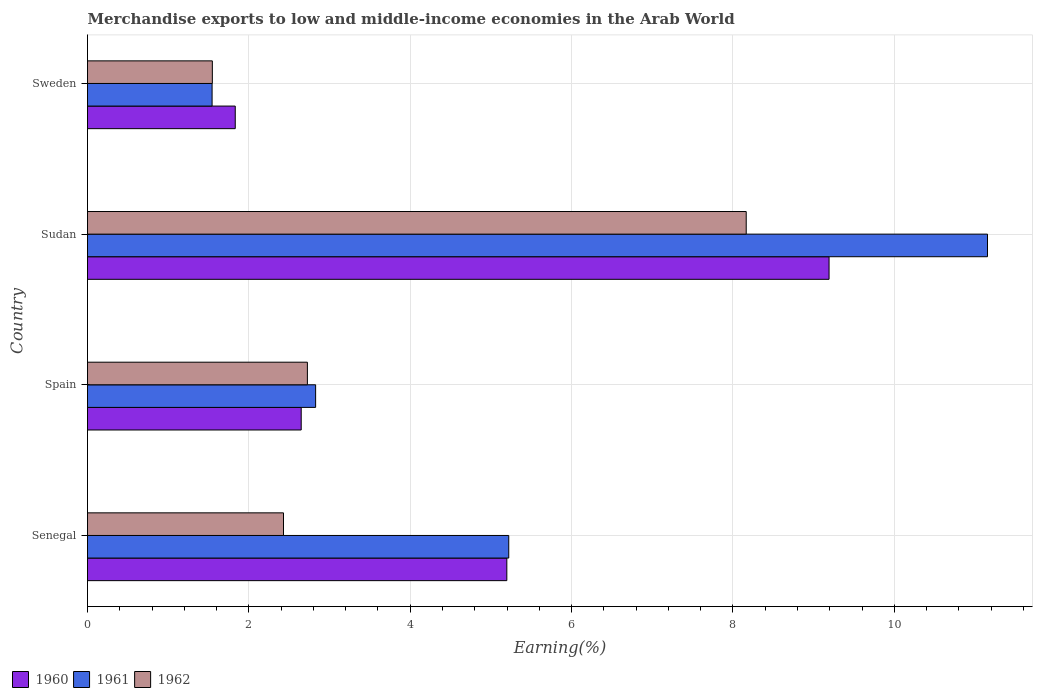Are the number of bars per tick equal to the number of legend labels?
Keep it short and to the point. Yes. How many bars are there on the 2nd tick from the bottom?
Provide a succinct answer. 3. What is the label of the 2nd group of bars from the top?
Provide a succinct answer. Sudan. In how many cases, is the number of bars for a given country not equal to the number of legend labels?
Your answer should be compact. 0. What is the percentage of amount earned from merchandise exports in 1960 in Spain?
Ensure brevity in your answer.  2.65. Across all countries, what is the maximum percentage of amount earned from merchandise exports in 1961?
Offer a terse response. 11.15. Across all countries, what is the minimum percentage of amount earned from merchandise exports in 1961?
Your answer should be compact. 1.54. In which country was the percentage of amount earned from merchandise exports in 1962 maximum?
Provide a succinct answer. Sudan. In which country was the percentage of amount earned from merchandise exports in 1962 minimum?
Provide a short and direct response. Sweden. What is the total percentage of amount earned from merchandise exports in 1962 in the graph?
Your response must be concise. 14.87. What is the difference between the percentage of amount earned from merchandise exports in 1962 in Senegal and that in Sudan?
Offer a terse response. -5.74. What is the difference between the percentage of amount earned from merchandise exports in 1961 in Sudan and the percentage of amount earned from merchandise exports in 1962 in Senegal?
Give a very brief answer. 8.73. What is the average percentage of amount earned from merchandise exports in 1961 per country?
Offer a terse response. 5.19. What is the difference between the percentage of amount earned from merchandise exports in 1961 and percentage of amount earned from merchandise exports in 1962 in Sweden?
Make the answer very short. -0. In how many countries, is the percentage of amount earned from merchandise exports in 1961 greater than 3.2 %?
Provide a succinct answer. 2. What is the ratio of the percentage of amount earned from merchandise exports in 1962 in Senegal to that in Sweden?
Your answer should be very brief. 1.57. What is the difference between the highest and the second highest percentage of amount earned from merchandise exports in 1960?
Provide a succinct answer. 3.99. What is the difference between the highest and the lowest percentage of amount earned from merchandise exports in 1960?
Offer a terse response. 7.36. In how many countries, is the percentage of amount earned from merchandise exports in 1960 greater than the average percentage of amount earned from merchandise exports in 1960 taken over all countries?
Make the answer very short. 2. Is the sum of the percentage of amount earned from merchandise exports in 1960 in Senegal and Sudan greater than the maximum percentage of amount earned from merchandise exports in 1961 across all countries?
Ensure brevity in your answer.  Yes. What does the 3rd bar from the top in Spain represents?
Offer a very short reply. 1960. What does the 1st bar from the bottom in Spain represents?
Offer a terse response. 1960. Is it the case that in every country, the sum of the percentage of amount earned from merchandise exports in 1961 and percentage of amount earned from merchandise exports in 1960 is greater than the percentage of amount earned from merchandise exports in 1962?
Your answer should be compact. Yes. How many bars are there?
Make the answer very short. 12. Are all the bars in the graph horizontal?
Provide a short and direct response. Yes. How many countries are there in the graph?
Offer a very short reply. 4. Are the values on the major ticks of X-axis written in scientific E-notation?
Your answer should be very brief. No. Does the graph contain any zero values?
Make the answer very short. No. Does the graph contain grids?
Your answer should be compact. Yes. Where does the legend appear in the graph?
Provide a short and direct response. Bottom left. What is the title of the graph?
Offer a terse response. Merchandise exports to low and middle-income economies in the Arab World. What is the label or title of the X-axis?
Keep it short and to the point. Earning(%). What is the Earning(%) of 1960 in Senegal?
Provide a short and direct response. 5.2. What is the Earning(%) in 1961 in Senegal?
Keep it short and to the point. 5.22. What is the Earning(%) in 1962 in Senegal?
Keep it short and to the point. 2.43. What is the Earning(%) in 1960 in Spain?
Provide a succinct answer. 2.65. What is the Earning(%) of 1961 in Spain?
Ensure brevity in your answer.  2.83. What is the Earning(%) of 1962 in Spain?
Offer a very short reply. 2.73. What is the Earning(%) in 1960 in Sudan?
Keep it short and to the point. 9.19. What is the Earning(%) of 1961 in Sudan?
Provide a short and direct response. 11.15. What is the Earning(%) of 1962 in Sudan?
Your response must be concise. 8.16. What is the Earning(%) of 1960 in Sweden?
Your answer should be very brief. 1.83. What is the Earning(%) of 1961 in Sweden?
Keep it short and to the point. 1.54. What is the Earning(%) in 1962 in Sweden?
Provide a succinct answer. 1.55. Across all countries, what is the maximum Earning(%) of 1960?
Offer a terse response. 9.19. Across all countries, what is the maximum Earning(%) of 1961?
Give a very brief answer. 11.15. Across all countries, what is the maximum Earning(%) of 1962?
Keep it short and to the point. 8.16. Across all countries, what is the minimum Earning(%) of 1960?
Your answer should be compact. 1.83. Across all countries, what is the minimum Earning(%) of 1961?
Your response must be concise. 1.54. Across all countries, what is the minimum Earning(%) in 1962?
Make the answer very short. 1.55. What is the total Earning(%) in 1960 in the graph?
Your answer should be compact. 18.87. What is the total Earning(%) in 1961 in the graph?
Provide a short and direct response. 20.75. What is the total Earning(%) of 1962 in the graph?
Your answer should be very brief. 14.87. What is the difference between the Earning(%) of 1960 in Senegal and that in Spain?
Your answer should be very brief. 2.55. What is the difference between the Earning(%) of 1961 in Senegal and that in Spain?
Your answer should be compact. 2.39. What is the difference between the Earning(%) in 1962 in Senegal and that in Spain?
Offer a terse response. -0.3. What is the difference between the Earning(%) of 1960 in Senegal and that in Sudan?
Offer a very short reply. -3.99. What is the difference between the Earning(%) in 1961 in Senegal and that in Sudan?
Offer a terse response. -5.93. What is the difference between the Earning(%) of 1962 in Senegal and that in Sudan?
Your response must be concise. -5.74. What is the difference between the Earning(%) in 1960 in Senegal and that in Sweden?
Provide a succinct answer. 3.37. What is the difference between the Earning(%) in 1961 in Senegal and that in Sweden?
Give a very brief answer. 3.68. What is the difference between the Earning(%) of 1962 in Senegal and that in Sweden?
Provide a short and direct response. 0.88. What is the difference between the Earning(%) of 1960 in Spain and that in Sudan?
Ensure brevity in your answer.  -6.54. What is the difference between the Earning(%) in 1961 in Spain and that in Sudan?
Your response must be concise. -8.33. What is the difference between the Earning(%) of 1962 in Spain and that in Sudan?
Ensure brevity in your answer.  -5.44. What is the difference between the Earning(%) in 1960 in Spain and that in Sweden?
Keep it short and to the point. 0.82. What is the difference between the Earning(%) of 1961 in Spain and that in Sweden?
Make the answer very short. 1.28. What is the difference between the Earning(%) of 1962 in Spain and that in Sweden?
Provide a short and direct response. 1.18. What is the difference between the Earning(%) in 1960 in Sudan and that in Sweden?
Ensure brevity in your answer.  7.36. What is the difference between the Earning(%) of 1961 in Sudan and that in Sweden?
Your answer should be compact. 9.61. What is the difference between the Earning(%) in 1962 in Sudan and that in Sweden?
Offer a very short reply. 6.62. What is the difference between the Earning(%) of 1960 in Senegal and the Earning(%) of 1961 in Spain?
Offer a very short reply. 2.37. What is the difference between the Earning(%) of 1960 in Senegal and the Earning(%) of 1962 in Spain?
Offer a very short reply. 2.47. What is the difference between the Earning(%) in 1961 in Senegal and the Earning(%) in 1962 in Spain?
Provide a short and direct response. 2.5. What is the difference between the Earning(%) in 1960 in Senegal and the Earning(%) in 1961 in Sudan?
Your answer should be compact. -5.96. What is the difference between the Earning(%) of 1960 in Senegal and the Earning(%) of 1962 in Sudan?
Ensure brevity in your answer.  -2.97. What is the difference between the Earning(%) of 1961 in Senegal and the Earning(%) of 1962 in Sudan?
Offer a very short reply. -2.94. What is the difference between the Earning(%) in 1960 in Senegal and the Earning(%) in 1961 in Sweden?
Offer a very short reply. 3.65. What is the difference between the Earning(%) of 1960 in Senegal and the Earning(%) of 1962 in Sweden?
Offer a very short reply. 3.65. What is the difference between the Earning(%) in 1961 in Senegal and the Earning(%) in 1962 in Sweden?
Make the answer very short. 3.67. What is the difference between the Earning(%) of 1960 in Spain and the Earning(%) of 1961 in Sudan?
Provide a succinct answer. -8.51. What is the difference between the Earning(%) in 1960 in Spain and the Earning(%) in 1962 in Sudan?
Ensure brevity in your answer.  -5.52. What is the difference between the Earning(%) of 1961 in Spain and the Earning(%) of 1962 in Sudan?
Offer a terse response. -5.34. What is the difference between the Earning(%) in 1960 in Spain and the Earning(%) in 1961 in Sweden?
Your answer should be compact. 1.1. What is the difference between the Earning(%) of 1960 in Spain and the Earning(%) of 1962 in Sweden?
Offer a very short reply. 1.1. What is the difference between the Earning(%) in 1961 in Spain and the Earning(%) in 1962 in Sweden?
Keep it short and to the point. 1.28. What is the difference between the Earning(%) of 1960 in Sudan and the Earning(%) of 1961 in Sweden?
Provide a short and direct response. 7.65. What is the difference between the Earning(%) of 1960 in Sudan and the Earning(%) of 1962 in Sweden?
Provide a succinct answer. 7.64. What is the difference between the Earning(%) in 1961 in Sudan and the Earning(%) in 1962 in Sweden?
Offer a very short reply. 9.61. What is the average Earning(%) in 1960 per country?
Make the answer very short. 4.72. What is the average Earning(%) of 1961 per country?
Your response must be concise. 5.19. What is the average Earning(%) in 1962 per country?
Give a very brief answer. 3.72. What is the difference between the Earning(%) of 1960 and Earning(%) of 1961 in Senegal?
Your response must be concise. -0.02. What is the difference between the Earning(%) of 1960 and Earning(%) of 1962 in Senegal?
Offer a very short reply. 2.77. What is the difference between the Earning(%) in 1961 and Earning(%) in 1962 in Senegal?
Offer a terse response. 2.79. What is the difference between the Earning(%) of 1960 and Earning(%) of 1961 in Spain?
Your answer should be compact. -0.18. What is the difference between the Earning(%) in 1960 and Earning(%) in 1962 in Spain?
Your answer should be very brief. -0.08. What is the difference between the Earning(%) of 1961 and Earning(%) of 1962 in Spain?
Ensure brevity in your answer.  0.1. What is the difference between the Earning(%) of 1960 and Earning(%) of 1961 in Sudan?
Your answer should be compact. -1.96. What is the difference between the Earning(%) of 1960 and Earning(%) of 1962 in Sudan?
Your answer should be very brief. 1.03. What is the difference between the Earning(%) in 1961 and Earning(%) in 1962 in Sudan?
Offer a terse response. 2.99. What is the difference between the Earning(%) in 1960 and Earning(%) in 1961 in Sweden?
Make the answer very short. 0.29. What is the difference between the Earning(%) of 1960 and Earning(%) of 1962 in Sweden?
Your response must be concise. 0.28. What is the difference between the Earning(%) of 1961 and Earning(%) of 1962 in Sweden?
Ensure brevity in your answer.  -0. What is the ratio of the Earning(%) of 1960 in Senegal to that in Spain?
Give a very brief answer. 1.96. What is the ratio of the Earning(%) of 1961 in Senegal to that in Spain?
Give a very brief answer. 1.85. What is the ratio of the Earning(%) in 1962 in Senegal to that in Spain?
Your answer should be compact. 0.89. What is the ratio of the Earning(%) of 1960 in Senegal to that in Sudan?
Provide a succinct answer. 0.57. What is the ratio of the Earning(%) of 1961 in Senegal to that in Sudan?
Offer a terse response. 0.47. What is the ratio of the Earning(%) of 1962 in Senegal to that in Sudan?
Give a very brief answer. 0.3. What is the ratio of the Earning(%) of 1960 in Senegal to that in Sweden?
Offer a terse response. 2.84. What is the ratio of the Earning(%) in 1961 in Senegal to that in Sweden?
Ensure brevity in your answer.  3.38. What is the ratio of the Earning(%) in 1962 in Senegal to that in Sweden?
Make the answer very short. 1.57. What is the ratio of the Earning(%) of 1960 in Spain to that in Sudan?
Offer a very short reply. 0.29. What is the ratio of the Earning(%) in 1961 in Spain to that in Sudan?
Your answer should be very brief. 0.25. What is the ratio of the Earning(%) of 1962 in Spain to that in Sudan?
Offer a very short reply. 0.33. What is the ratio of the Earning(%) of 1960 in Spain to that in Sweden?
Keep it short and to the point. 1.45. What is the ratio of the Earning(%) of 1961 in Spain to that in Sweden?
Provide a succinct answer. 1.83. What is the ratio of the Earning(%) of 1962 in Spain to that in Sweden?
Provide a short and direct response. 1.76. What is the ratio of the Earning(%) of 1960 in Sudan to that in Sweden?
Provide a short and direct response. 5.02. What is the ratio of the Earning(%) in 1961 in Sudan to that in Sweden?
Your response must be concise. 7.22. What is the ratio of the Earning(%) of 1962 in Sudan to that in Sweden?
Make the answer very short. 5.28. What is the difference between the highest and the second highest Earning(%) of 1960?
Give a very brief answer. 3.99. What is the difference between the highest and the second highest Earning(%) of 1961?
Provide a short and direct response. 5.93. What is the difference between the highest and the second highest Earning(%) of 1962?
Your answer should be very brief. 5.44. What is the difference between the highest and the lowest Earning(%) of 1960?
Offer a very short reply. 7.36. What is the difference between the highest and the lowest Earning(%) of 1961?
Your answer should be very brief. 9.61. What is the difference between the highest and the lowest Earning(%) of 1962?
Provide a short and direct response. 6.62. 